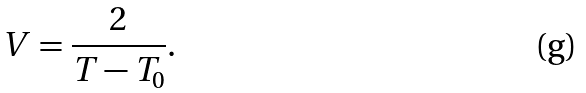Convert formula to latex. <formula><loc_0><loc_0><loc_500><loc_500>V = \frac { 2 } { T - T _ { 0 } } .</formula> 